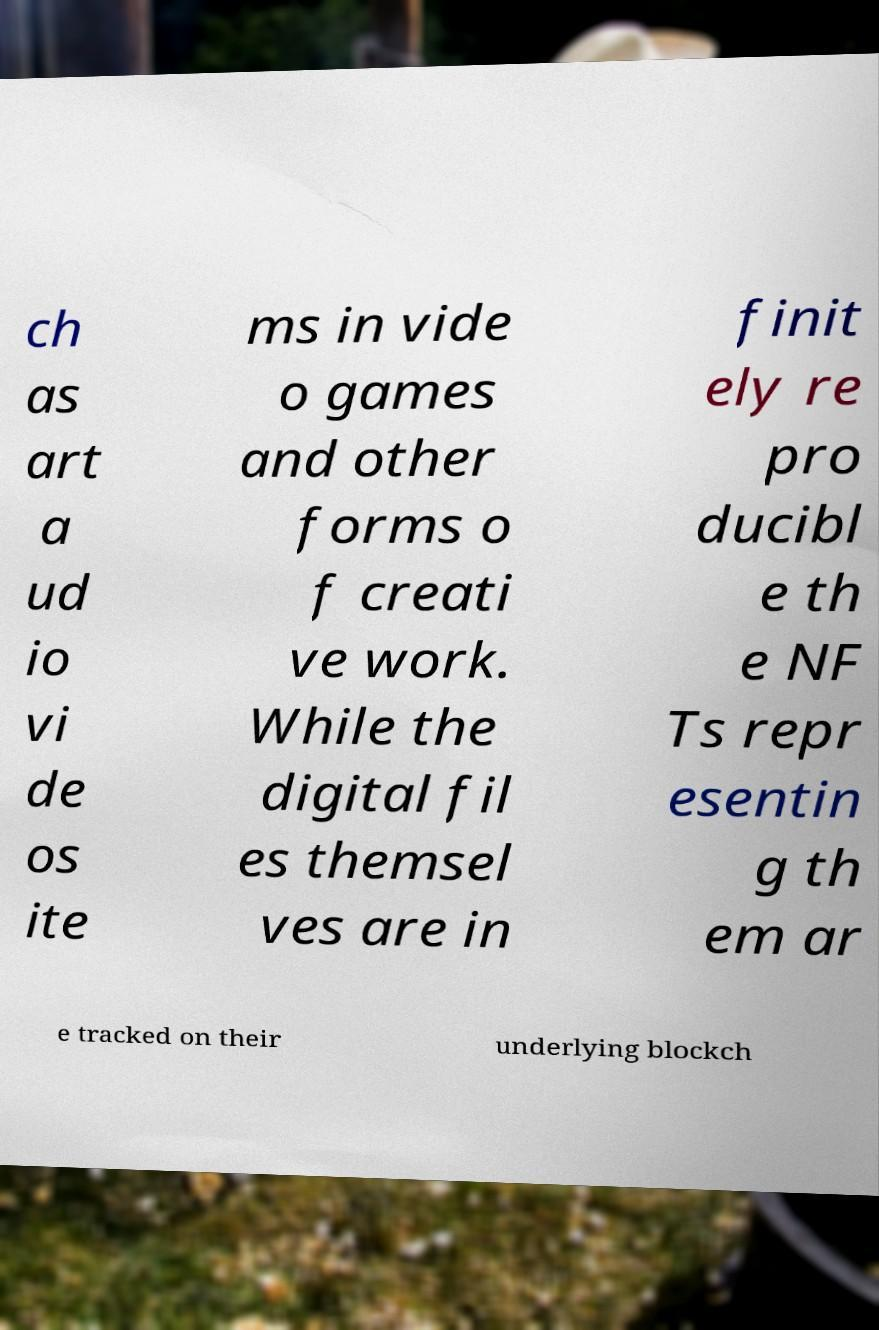Please identify and transcribe the text found in this image. ch as art a ud io vi de os ite ms in vide o games and other forms o f creati ve work. While the digital fil es themsel ves are in finit ely re pro ducibl e th e NF Ts repr esentin g th em ar e tracked on their underlying blockch 